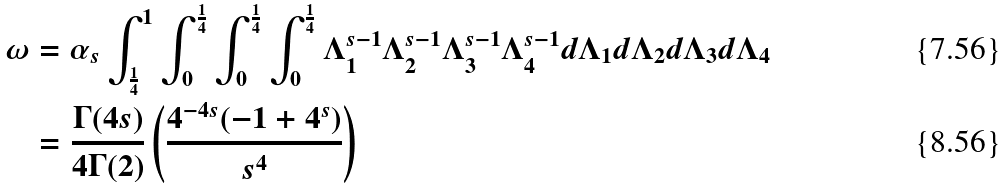Convert formula to latex. <formula><loc_0><loc_0><loc_500><loc_500>\omega & = \alpha _ { s } \int _ { \frac { 1 } { 4 } } ^ { 1 } \int _ { 0 } ^ { \frac { 1 } { 4 } } \int _ { 0 } ^ { \frac { 1 } { 4 } } \int _ { 0 } ^ { \frac { 1 } { 4 } } \Lambda _ { 1 } ^ { s - 1 } \Lambda _ { 2 } ^ { s - 1 } \Lambda _ { 3 } ^ { s - 1 } \Lambda _ { 4 } ^ { s - 1 } d \Lambda _ { 1 } d \Lambda _ { 2 } d \Lambda _ { 3 } d \Lambda _ { 4 } \\ & = \frac { \Gamma ( 4 s ) } { 4 \Gamma ( 2 ) } \left ( \frac { 4 ^ { - 4 s } ( - 1 + 4 ^ { s } ) } { s ^ { 4 } } \right )</formula> 